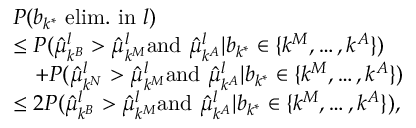<formula> <loc_0><loc_0><loc_500><loc_500>\begin{array} { r l } & { P ( b _ { k ^ { * } } e l i m . i n l ) } \\ & { \leq P ( \hat { \mu } _ { k ^ { B } } ^ { l } > \hat { \mu } _ { k ^ { M } } ^ { l } a n d \, \hat { \mu } _ { k ^ { A } } ^ { l } | b _ { k ^ { * } } \in \{ k ^ { M } , \dots , k ^ { A } \} ) } \\ & { \quad + P ( \hat { \mu } _ { k ^ { N } } ^ { l } > \hat { \mu } _ { k ^ { M } } ^ { l } a n d \, \hat { \mu } _ { k ^ { A } } ^ { l } | b _ { k ^ { * } } \in \{ k ^ { M } , \dots , k ^ { A } \} ) } \\ & { \leq 2 P ( \hat { \mu } _ { k ^ { B } } ^ { l } > \hat { \mu } _ { k ^ { M } } ^ { l } a n d \, \hat { \mu } _ { k ^ { A } } ^ { l } | b _ { k ^ { * } } \in \{ k ^ { M } , \dots , k ^ { A } \} ) , } \end{array}</formula> 